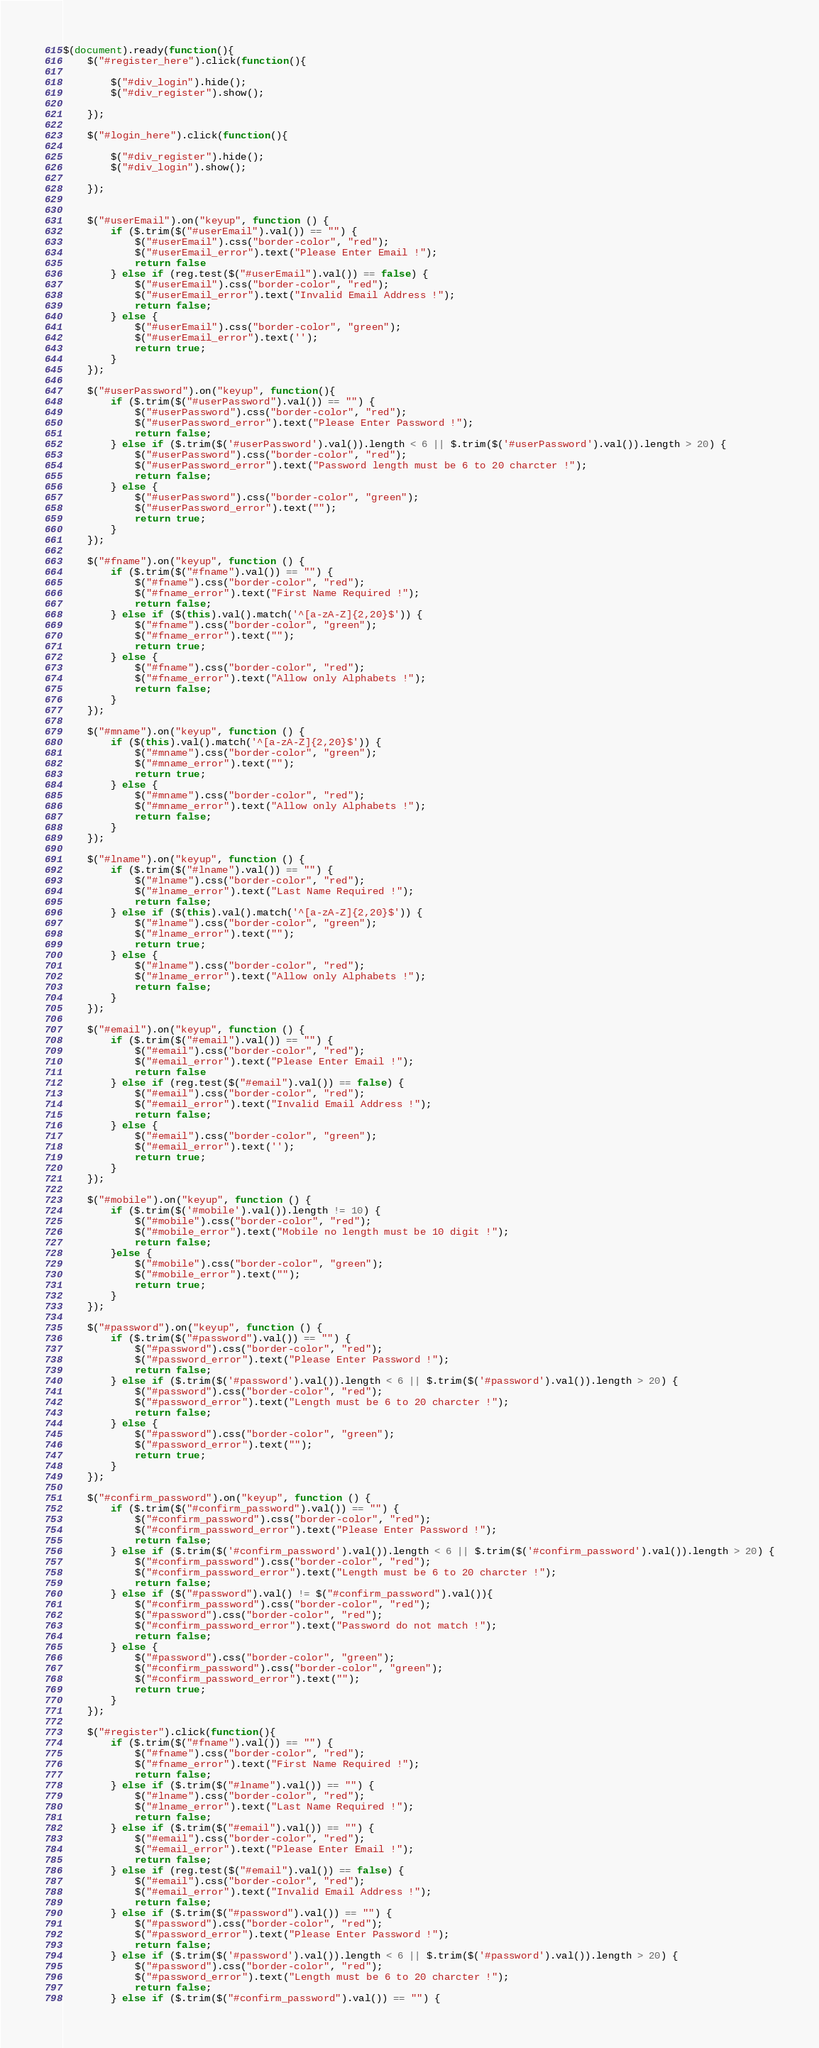<code> <loc_0><loc_0><loc_500><loc_500><_JavaScript_>$(document).ready(function(){
    $("#register_here").click(function(){

        $("#div_login").hide();
        $("#div_register").show();

    });
    
    $("#login_here").click(function(){

        $("#div_register").hide();
        $("#div_login").show();

    });


    $("#userEmail").on("keyup", function () {
        if ($.trim($("#userEmail").val()) == "") {
            $("#userEmail").css("border-color", "red");
            $("#userEmail_error").text("Please Enter Email !");
            return false
        } else if (reg.test($("#userEmail").val()) == false) {
            $("#userEmail").css("border-color", "red");
            $("#userEmail_error").text("Invalid Email Address !");
            return false;
        } else {
            $("#userEmail").css("border-color", "green");
            $("#userEmail_error").text('');
            return true;
        }
    });

    $("#userPassword").on("keyup", function(){
        if ($.trim($("#userPassword").val()) == "") {
            $("#userPassword").css("border-color", "red");
            $("#userPassword_error").text("Please Enter Password !");
            return false;
        } else if ($.trim($('#userPassword').val()).length < 6 || $.trim($('#userPassword').val()).length > 20) {
            $("#userPassword").css("border-color", "red");
            $("#userPassword_error").text("Password length must be 6 to 20 charcter !");
            return false;
        } else {
            $("#userPassword").css("border-color", "green");
            $("#userPassword_error").text("");
            return true;
        }
    });

    $("#fname").on("keyup", function () {
        if ($.trim($("#fname").val()) == "") {
            $("#fname").css("border-color", "red");
            $("#fname_error").text("First Name Required !");
            return false;
        } else if ($(this).val().match('^[a-zA-Z]{2,20}$')) {
            $("#fname").css("border-color", "green");
            $("#fname_error").text("");
            return true;
        } else {
            $("#fname").css("border-color", "red");
            $("#fname_error").text("Allow only Alphabets !");
            return false;
        }
    });

    $("#mname").on("keyup", function () {
        if ($(this).val().match('^[a-zA-Z]{2,20}$')) {
            $("#mname").css("border-color", "green");
            $("#mname_error").text("");
            return true;
        } else {
            $("#mname").css("border-color", "red");
            $("#mname_error").text("Allow only Alphabets !");
            return false;
        }
    });

    $("#lname").on("keyup", function () {
        if ($.trim($("#lname").val()) == "") {
            $("#lname").css("border-color", "red");
            $("#lname_error").text("Last Name Required !");
            return false;
        } else if ($(this).val().match('^[a-zA-Z]{2,20}$')) {
            $("#lname").css("border-color", "green");
            $("#lname_error").text("");
            return true;
        } else {
            $("#lname").css("border-color", "red");
            $("#lname_error").text("Allow only Alphabets !");
            return false;
        }
    });

    $("#email").on("keyup", function () {
        if ($.trim($("#email").val()) == "") {
            $("#email").css("border-color", "red");
            $("#email_error").text("Please Enter Email !");
            return false
        } else if (reg.test($("#email").val()) == false) {
            $("#email").css("border-color", "red");
            $("#email_error").text("Invalid Email Address !");
            return false;
        } else {
            $("#email").css("border-color", "green");
            $("#email_error").text('');
            return true;
        }
    });

    $("#mobile").on("keyup", function () {
        if ($.trim($('#mobile').val()).length != 10) {
            $("#mobile").css("border-color", "red");
            $("#mobile_error").text("Mobile no length must be 10 digit !");
            return false;
        }else {
            $("#mobile").css("border-color", "green");
            $("#mobile_error").text("");
            return true;
        }
    });

    $("#password").on("keyup", function () {
        if ($.trim($("#password").val()) == "") {
            $("#password").css("border-color", "red");
            $("#password_error").text("Please Enter Password !");
            return false;
        } else if ($.trim($('#password').val()).length < 6 || $.trim($('#password').val()).length > 20) {
            $("#password").css("border-color", "red");
            $("#password_error").text("Length must be 6 to 20 charcter !");
            return false;
        } else {
            $("#password").css("border-color", "green");
            $("#password_error").text("");
            return true;
        }
    });

    $("#confirm_password").on("keyup", function () {
        if ($.trim($("#confirm_password").val()) == "") {
            $("#confirm_password").css("border-color", "red");
            $("#confirm_password_error").text("Please Enter Password !");
            return false;
        } else if ($.trim($('#confirm_password').val()).length < 6 || $.trim($('#confirm_password').val()).length > 20) {
            $("#confirm_password").css("border-color", "red");
            $("#confirm_password_error").text("Length must be 6 to 20 charcter !");
            return false;
        } else if ($("#password").val() != $("#confirm_password").val()){
            $("#confirm_password").css("border-color", "red");
            $("#password").css("border-color", "red");
            $("#confirm_password_error").text("Password do not match !");
            return false;
        } else {
            $("#password").css("border-color", "green");
            $("#confirm_password").css("border-color", "green");
            $("#confirm_password_error").text("");
            return true;
        }
    });

    $("#register").click(function(){
        if ($.trim($("#fname").val()) == "") {
            $("#fname").css("border-color", "red");
            $("#fname_error").text("First Name Required !");
            return false;
        } else if ($.trim($("#lname").val()) == "") {
            $("#lname").css("border-color", "red");
            $("#lname_error").text("Last Name Required !");
            return false;
        } else if ($.trim($("#email").val()) == "") {
            $("#email").css("border-color", "red");
            $("#email_error").text("Please Enter Email !");
            return false;
        } else if (reg.test($("#email").val()) == false) {
            $("#email").css("border-color", "red");
            $("#email_error").text("Invalid Email Address !");
            return false;
        } else if ($.trim($("#password").val()) == "") {
            $("#password").css("border-color", "red");
            $("#password_error").text("Please Enter Password !");
            return false;
        } else if ($.trim($('#password').val()).length < 6 || $.trim($('#password').val()).length > 20) {
            $("#password").css("border-color", "red");
            $("#password_error").text("Length must be 6 to 20 charcter !");
            return false;
        } else if ($.trim($("#confirm_password").val()) == "") {</code> 